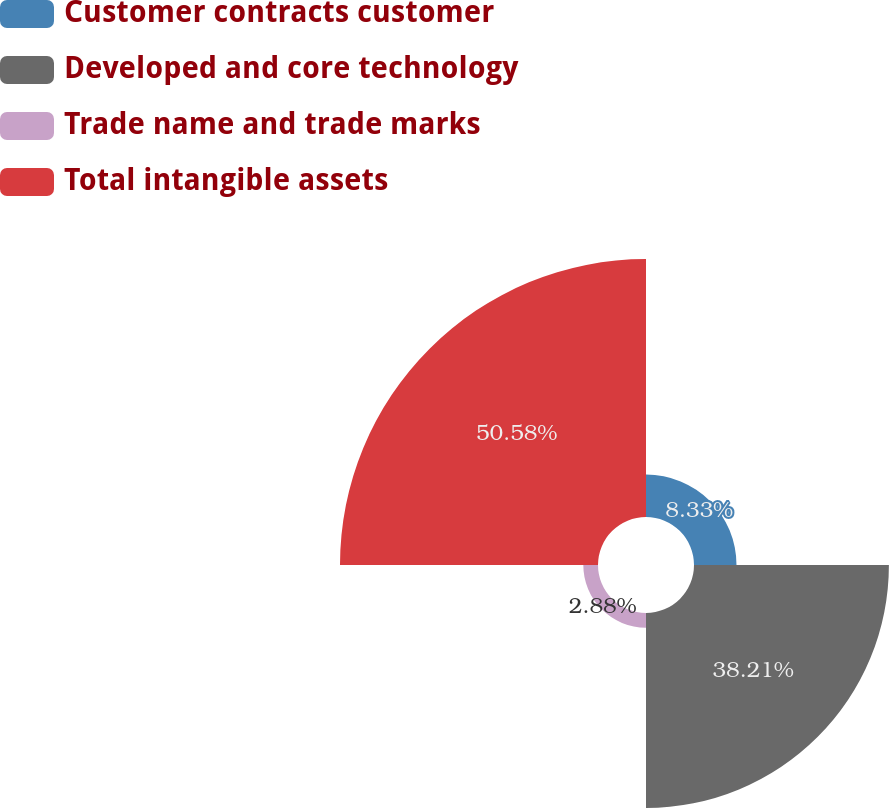Convert chart. <chart><loc_0><loc_0><loc_500><loc_500><pie_chart><fcel>Customer contracts customer<fcel>Developed and core technology<fcel>Trade name and trade marks<fcel>Total intangible assets<nl><fcel>8.33%<fcel>38.21%<fcel>2.88%<fcel>50.58%<nl></chart> 